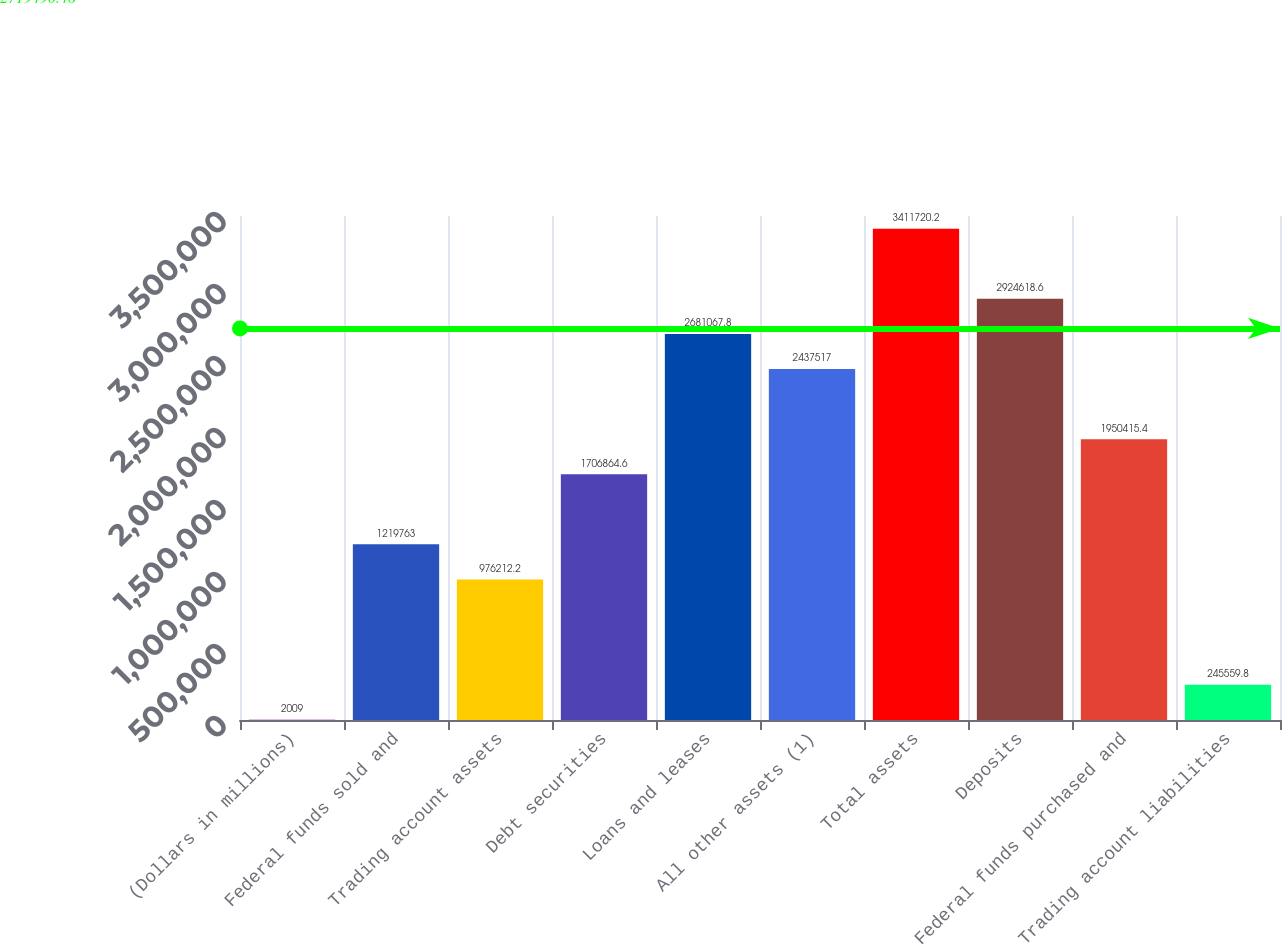Convert chart to OTSL. <chart><loc_0><loc_0><loc_500><loc_500><bar_chart><fcel>(Dollars in millions)<fcel>Federal funds sold and<fcel>Trading account assets<fcel>Debt securities<fcel>Loans and leases<fcel>All other assets (1)<fcel>Total assets<fcel>Deposits<fcel>Federal funds purchased and<fcel>Trading account liabilities<nl><fcel>2009<fcel>1.21976e+06<fcel>976212<fcel>1.70686e+06<fcel>2.68107e+06<fcel>2.43752e+06<fcel>3.41172e+06<fcel>2.92462e+06<fcel>1.95042e+06<fcel>245560<nl></chart> 